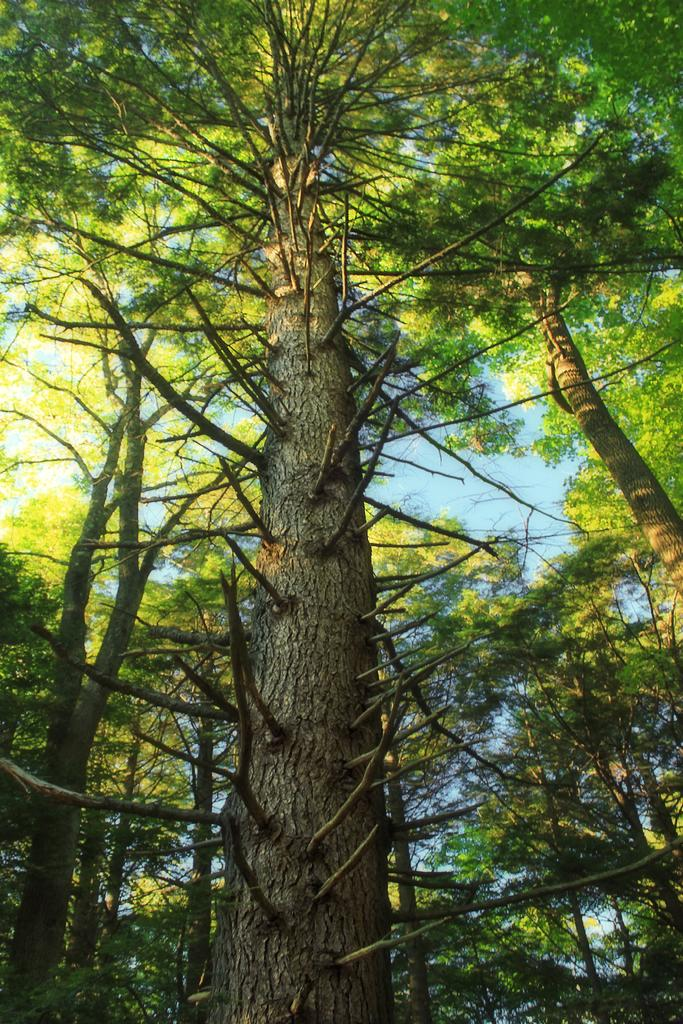What type of vegetation can be seen in the image? There are trees in the image. What part of the natural environment is visible in the image? The sky is visible in the background of the image. What type of furniture can be seen in the image? There is no furniture present in the image; it features trees and the sky. What type of educational setting is depicted in the image? There is no educational setting or class present in the image. 